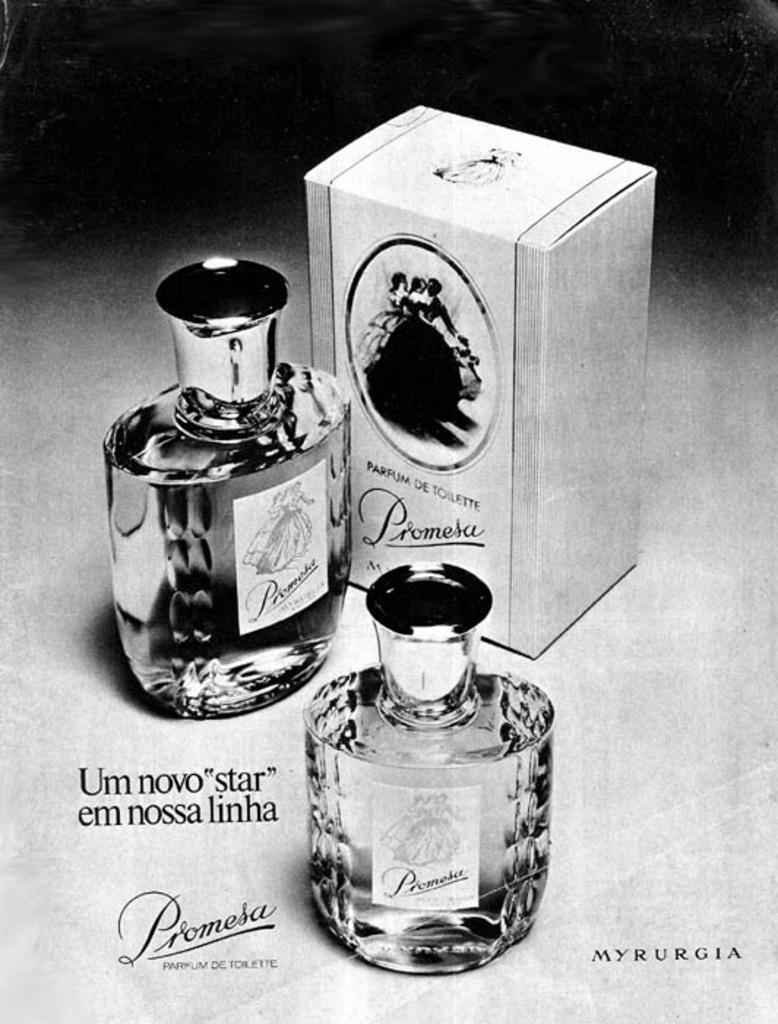What word is in the lower right corner of this ad?
Offer a terse response. Myrurgia. 